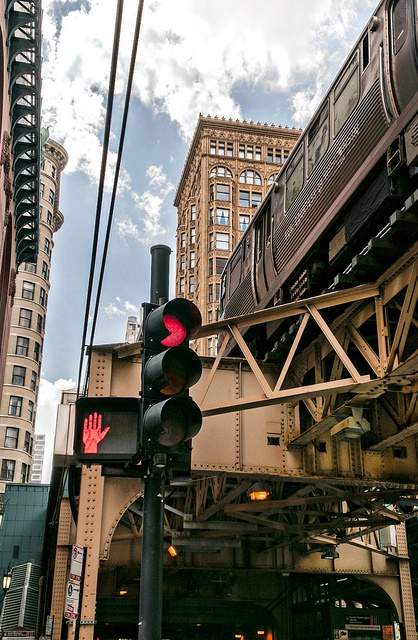Describe the objects in this image and their specific colors. I can see train in tan, black, gray, and darkgray tones, bus in tan, black, and gray tones, and traffic light in tan, black, gray, salmon, and maroon tones in this image. 